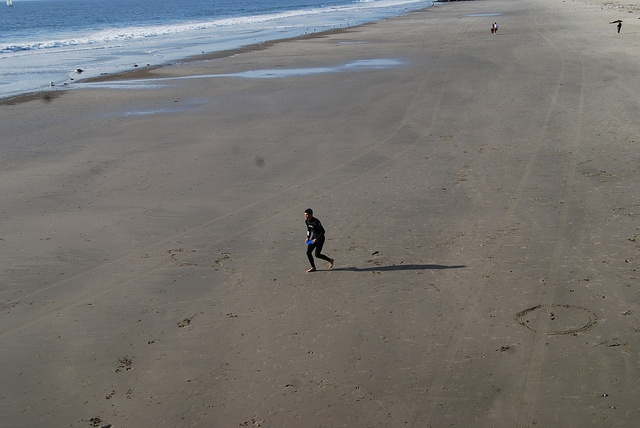Describe the objects in this image and their specific colors. I can see people in lightblue, black, and gray tones, people in lightblue, gray, and black tones, people in lightblue, gray, and black tones, people in lightblue, black, gray, and darkgray tones, and frisbee in lightblue, blue, darkblue, and gray tones in this image. 